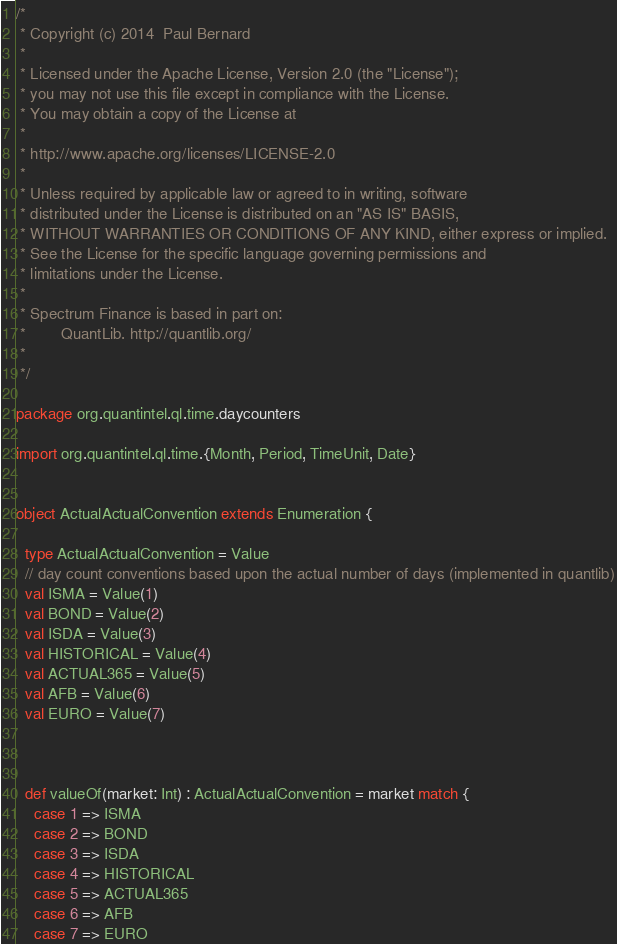<code> <loc_0><loc_0><loc_500><loc_500><_Scala_>/*
 * Copyright (c) 2014  Paul Bernard
 *
 * Licensed under the Apache License, Version 2.0 (the "License");
 * you may not use this file except in compliance with the License.
 * You may obtain a copy of the License at
 *
 * http://www.apache.org/licenses/LICENSE-2.0
 *
 * Unless required by applicable law or agreed to in writing, software
 * distributed under the License is distributed on an "AS IS" BASIS,
 * WITHOUT WARRANTIES OR CONDITIONS OF ANY KIND, either express or implied.
 * See the License for the specific language governing permissions and
 * limitations under the License.
 *
 * Spectrum Finance is based in part on:
 *        QuantLib. http://quantlib.org/
 *
 */

package org.quantintel.ql.time.daycounters

import org.quantintel.ql.time.{Month, Period, TimeUnit, Date}


object ActualActualConvention extends Enumeration {

  type ActualActualConvention = Value
  // day count conventions based upon the actual number of days (implemented in quantlib)
  val ISMA = Value(1)
  val BOND = Value(2)
  val ISDA = Value(3)
  val HISTORICAL = Value(4)
  val ACTUAL365 = Value(5)
  val AFB = Value(6)
  val EURO = Value(7)



  def valueOf(market: Int) : ActualActualConvention = market match {
    case 1 => ISMA
    case 2 => BOND
    case 3 => ISDA
    case 4 => HISTORICAL
    case 5 => ACTUAL365
    case 6 => AFB
    case 7 => EURO</code> 